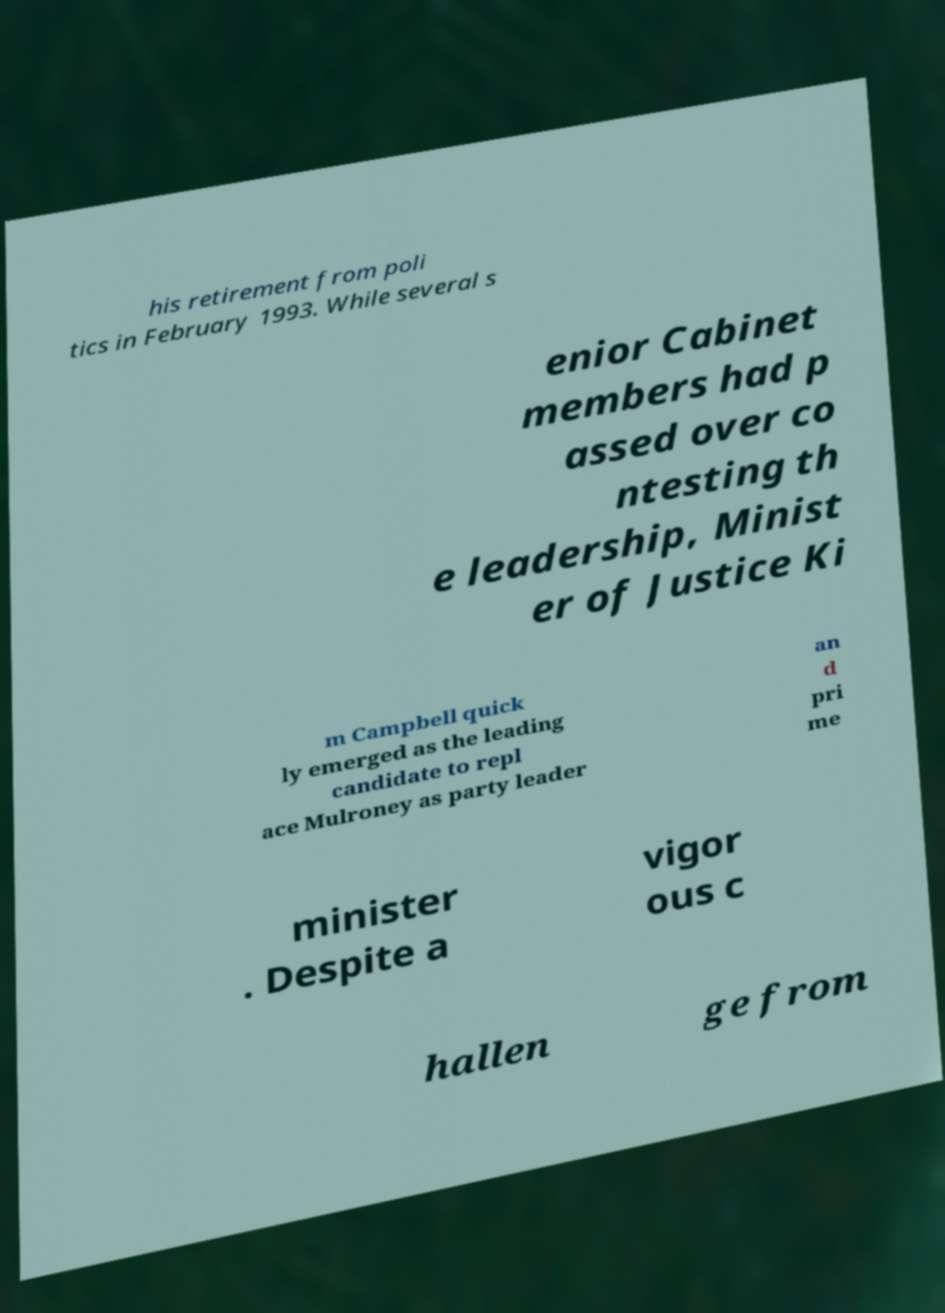Could you extract and type out the text from this image? his retirement from poli tics in February 1993. While several s enior Cabinet members had p assed over co ntesting th e leadership, Minist er of Justice Ki m Campbell quick ly emerged as the leading candidate to repl ace Mulroney as party leader an d pri me minister . Despite a vigor ous c hallen ge from 